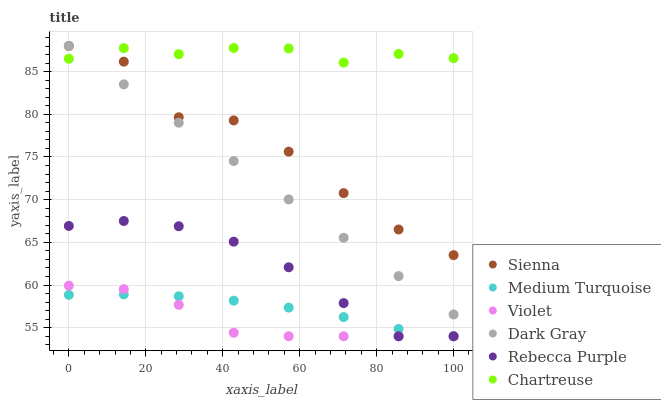Does Violet have the minimum area under the curve?
Answer yes or no. Yes. Does Chartreuse have the maximum area under the curve?
Answer yes or no. Yes. Does Sienna have the minimum area under the curve?
Answer yes or no. No. Does Sienna have the maximum area under the curve?
Answer yes or no. No. Is Dark Gray the smoothest?
Answer yes or no. Yes. Is Sienna the roughest?
Answer yes or no. Yes. Is Chartreuse the smoothest?
Answer yes or no. No. Is Chartreuse the roughest?
Answer yes or no. No. Does Rebecca Purple have the lowest value?
Answer yes or no. Yes. Does Sienna have the lowest value?
Answer yes or no. No. Does Sienna have the highest value?
Answer yes or no. Yes. Does Chartreuse have the highest value?
Answer yes or no. No. Is Violet less than Chartreuse?
Answer yes or no. Yes. Is Dark Gray greater than Rebecca Purple?
Answer yes or no. Yes. Does Rebecca Purple intersect Medium Turquoise?
Answer yes or no. Yes. Is Rebecca Purple less than Medium Turquoise?
Answer yes or no. No. Is Rebecca Purple greater than Medium Turquoise?
Answer yes or no. No. Does Violet intersect Chartreuse?
Answer yes or no. No. 